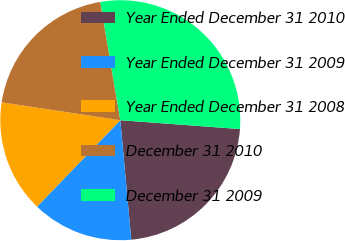Convert chart to OTSL. <chart><loc_0><loc_0><loc_500><loc_500><pie_chart><fcel>Year Ended December 31 2010<fcel>Year Ended December 31 2009<fcel>Year Ended December 31 2008<fcel>December 31 2010<fcel>December 31 2009<nl><fcel>22.37%<fcel>13.66%<fcel>15.18%<fcel>19.95%<fcel>28.84%<nl></chart> 